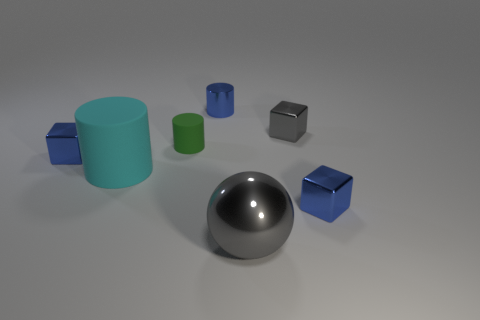Are there any other things that have the same material as the big gray ball?
Ensure brevity in your answer.  Yes. There is a tiny metallic thing that is the same color as the shiny ball; what shape is it?
Make the answer very short. Cube. How many cylinders are either gray shiny objects or big gray things?
Provide a succinct answer. 0. There is a cylinder in front of the block left of the small metal cylinder; what is its color?
Offer a very short reply. Cyan. There is a big cylinder; does it have the same color as the tiny cube that is to the left of the large gray metallic ball?
Offer a terse response. No. There is a cyan cylinder that is made of the same material as the small green object; what size is it?
Provide a succinct answer. Large. The metallic thing that is the same color as the big shiny ball is what size?
Give a very brief answer. Small. Is the color of the big metal sphere the same as the small matte cylinder?
Offer a terse response. No. Is there a green object in front of the blue object that is on the right side of the small gray metallic thing that is behind the big cyan cylinder?
Ensure brevity in your answer.  No. How many cylinders have the same size as the cyan matte object?
Provide a short and direct response. 0. 